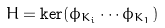<formula> <loc_0><loc_0><loc_500><loc_500>H = \ker ( \phi _ { K _ { i } } \cdots \phi _ { K _ { 1 } } )</formula> 